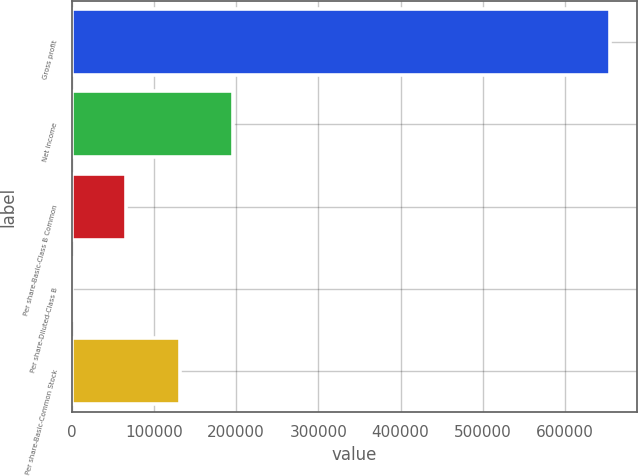<chart> <loc_0><loc_0><loc_500><loc_500><bar_chart><fcel>Gross profit<fcel>Net income<fcel>Per share-Basic-Class B Common<fcel>Per share-Diluted-Class B<fcel>Per share-Basic-Common Stock<nl><fcel>655220<fcel>196567<fcel>65522.7<fcel>0.73<fcel>131045<nl></chart> 